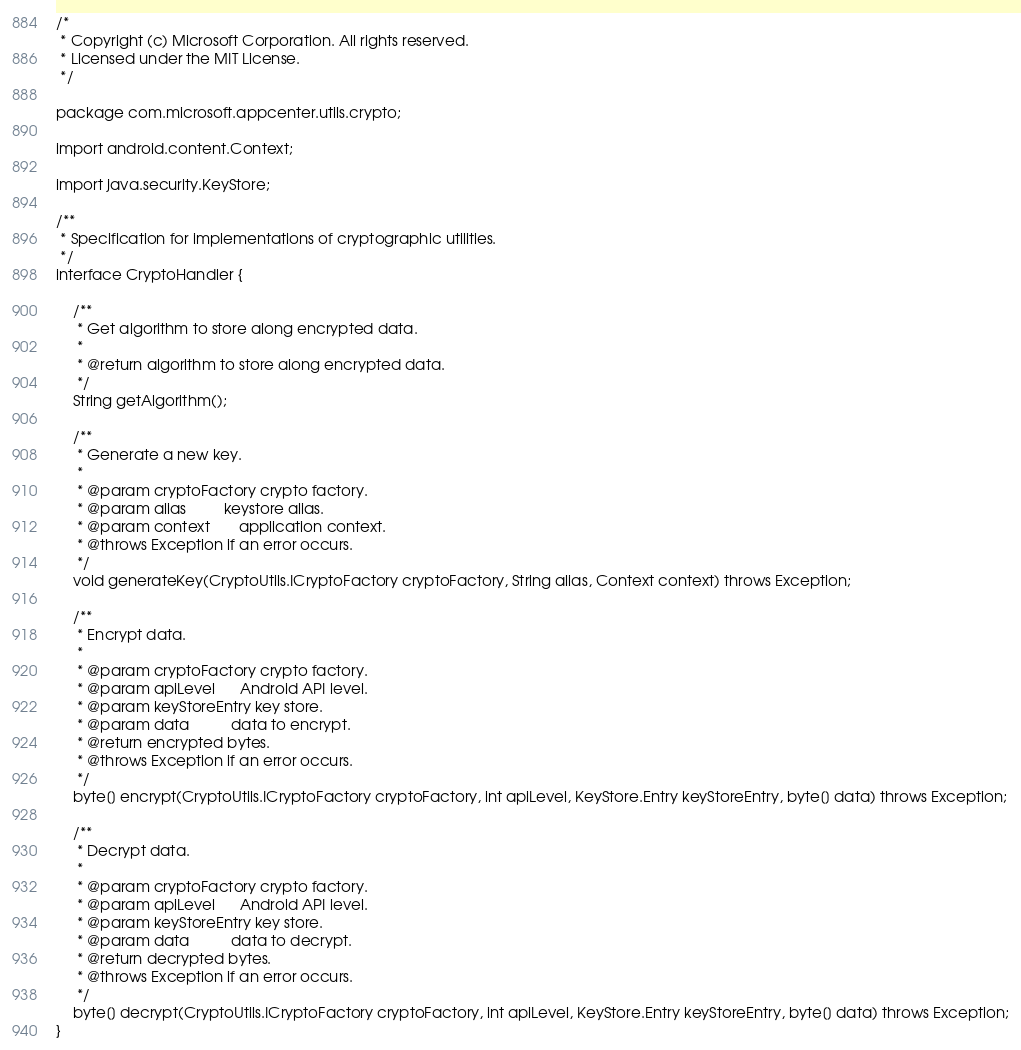Convert code to text. <code><loc_0><loc_0><loc_500><loc_500><_Java_>/*
 * Copyright (c) Microsoft Corporation. All rights reserved.
 * Licensed under the MIT License.
 */

package com.microsoft.appcenter.utils.crypto;

import android.content.Context;

import java.security.KeyStore;

/**
 * Specification for implementations of cryptographic utilities.
 */
interface CryptoHandler {

    /**
     * Get algorithm to store along encrypted data.
     *
     * @return algorithm to store along encrypted data.
     */
    String getAlgorithm();

    /**
     * Generate a new key.
     *
     * @param cryptoFactory crypto factory.
     * @param alias         keystore alias.
     * @param context       application context.
     * @throws Exception if an error occurs.
     */
    void generateKey(CryptoUtils.ICryptoFactory cryptoFactory, String alias, Context context) throws Exception;

    /**
     * Encrypt data.
     *
     * @param cryptoFactory crypto factory.
     * @param apiLevel      Android API level.
     * @param keyStoreEntry key store.
     * @param data          data to encrypt.
     * @return encrypted bytes.
     * @throws Exception if an error occurs.
     */
    byte[] encrypt(CryptoUtils.ICryptoFactory cryptoFactory, int apiLevel, KeyStore.Entry keyStoreEntry, byte[] data) throws Exception;

    /**
     * Decrypt data.
     *
     * @param cryptoFactory crypto factory.
     * @param apiLevel      Android API level.
     * @param keyStoreEntry key store.
     * @param data          data to decrypt.
     * @return decrypted bytes.
     * @throws Exception if an error occurs.
     */
    byte[] decrypt(CryptoUtils.ICryptoFactory cryptoFactory, int apiLevel, KeyStore.Entry keyStoreEntry, byte[] data) throws Exception;
}
</code> 